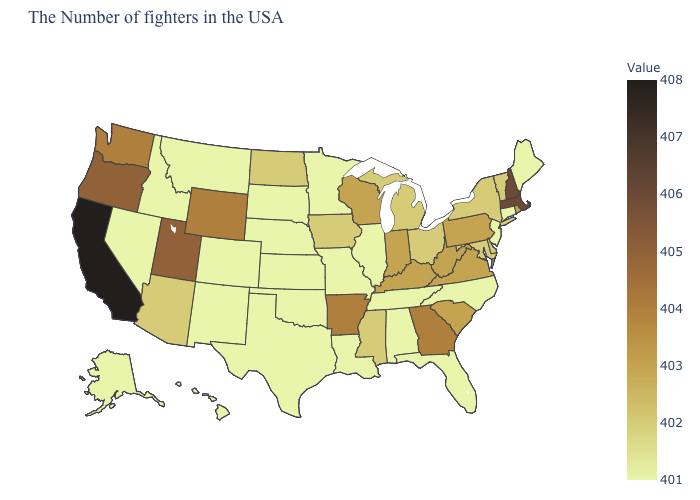Which states have the lowest value in the Northeast?
Keep it brief. Maine, Connecticut, New Jersey. Among the states that border Oklahoma , does Arkansas have the lowest value?
Write a very short answer. No. Which states have the highest value in the USA?
Keep it brief. California. Does Maine have the lowest value in the USA?
Be succinct. Yes. Among the states that border Nevada , which have the highest value?
Give a very brief answer. California. Does New Jersey have the lowest value in the Northeast?
Concise answer only. Yes. Does Massachusetts have the highest value in the Northeast?
Be succinct. Yes. 